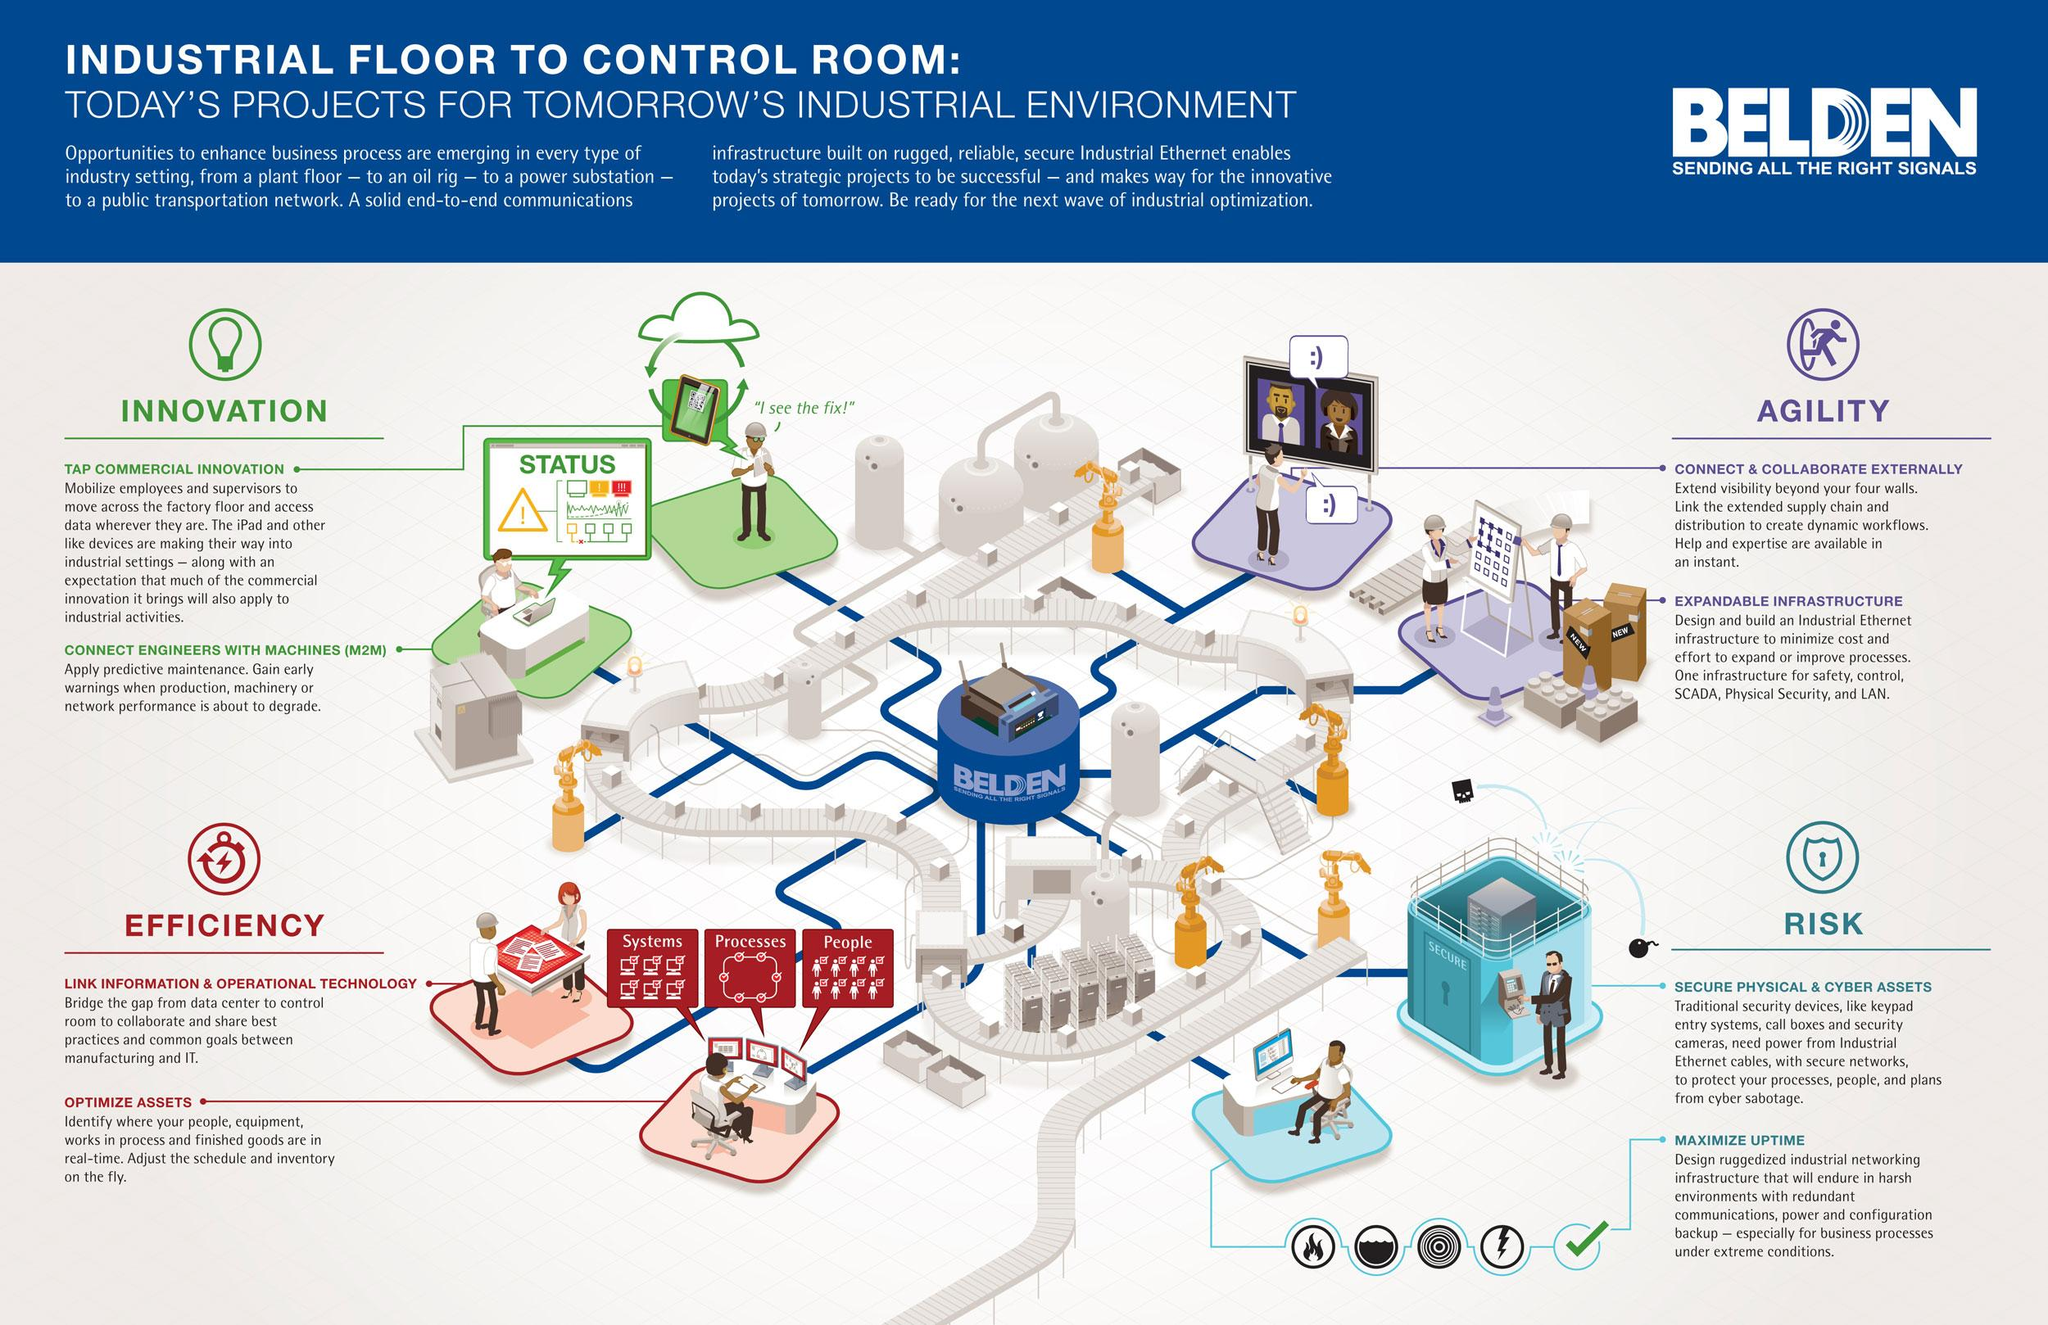Specify some key components in this picture. Two key factors drive innovation: commercial innovation that combines the creativity of designers with the technical expertise of engineers, and the integration of machines and technology through Machine-to-Machine (M2M) connectivity. Agility requires the key factors of external connection and collaboration, as well as an expandable infrastructure. When considering efficiency, it is important to consider the link between information and operational technology, as well as the optimization of assets. We must prioritize the management of potential risks, including the protection of physical and digital assets and ensuring maximum operational efficiency, in order to ensure the security and success of our organization. The three factors that contribute to asset optimization are systems, processes, and people. 